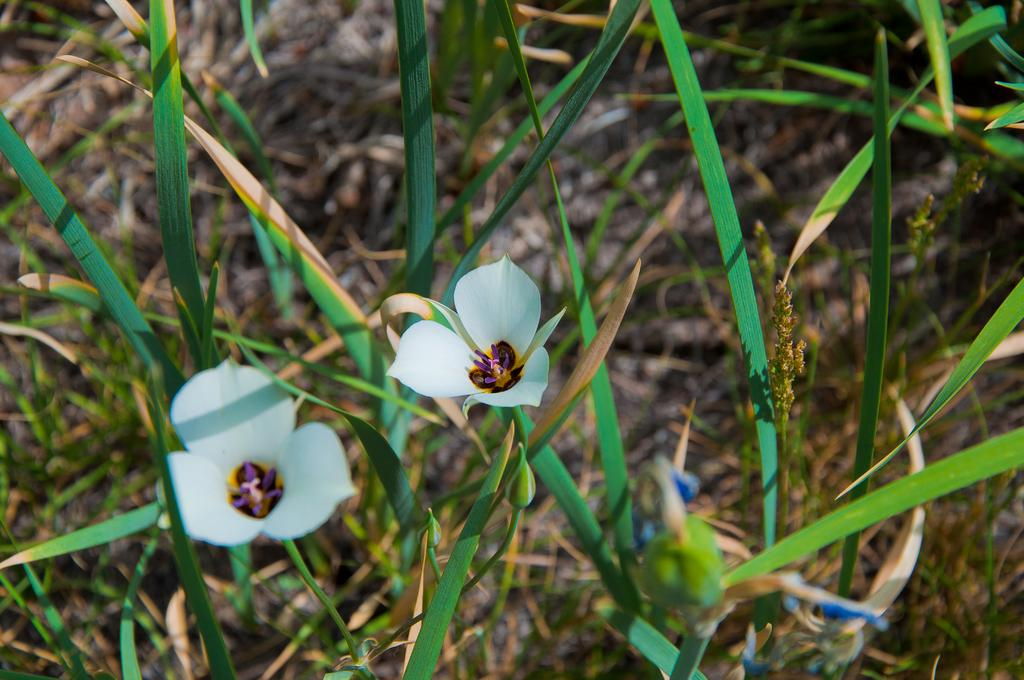What is the main subject of the image? The main subject of the image is a zoomed-in picture of plants. Can you describe any specific features of the plants in the image? There are two white flowers in the image. What type of sticks can be seen holding up the flowers in the image? There are no sticks visible in the image; the flowers are not being held up by any visible supports. 